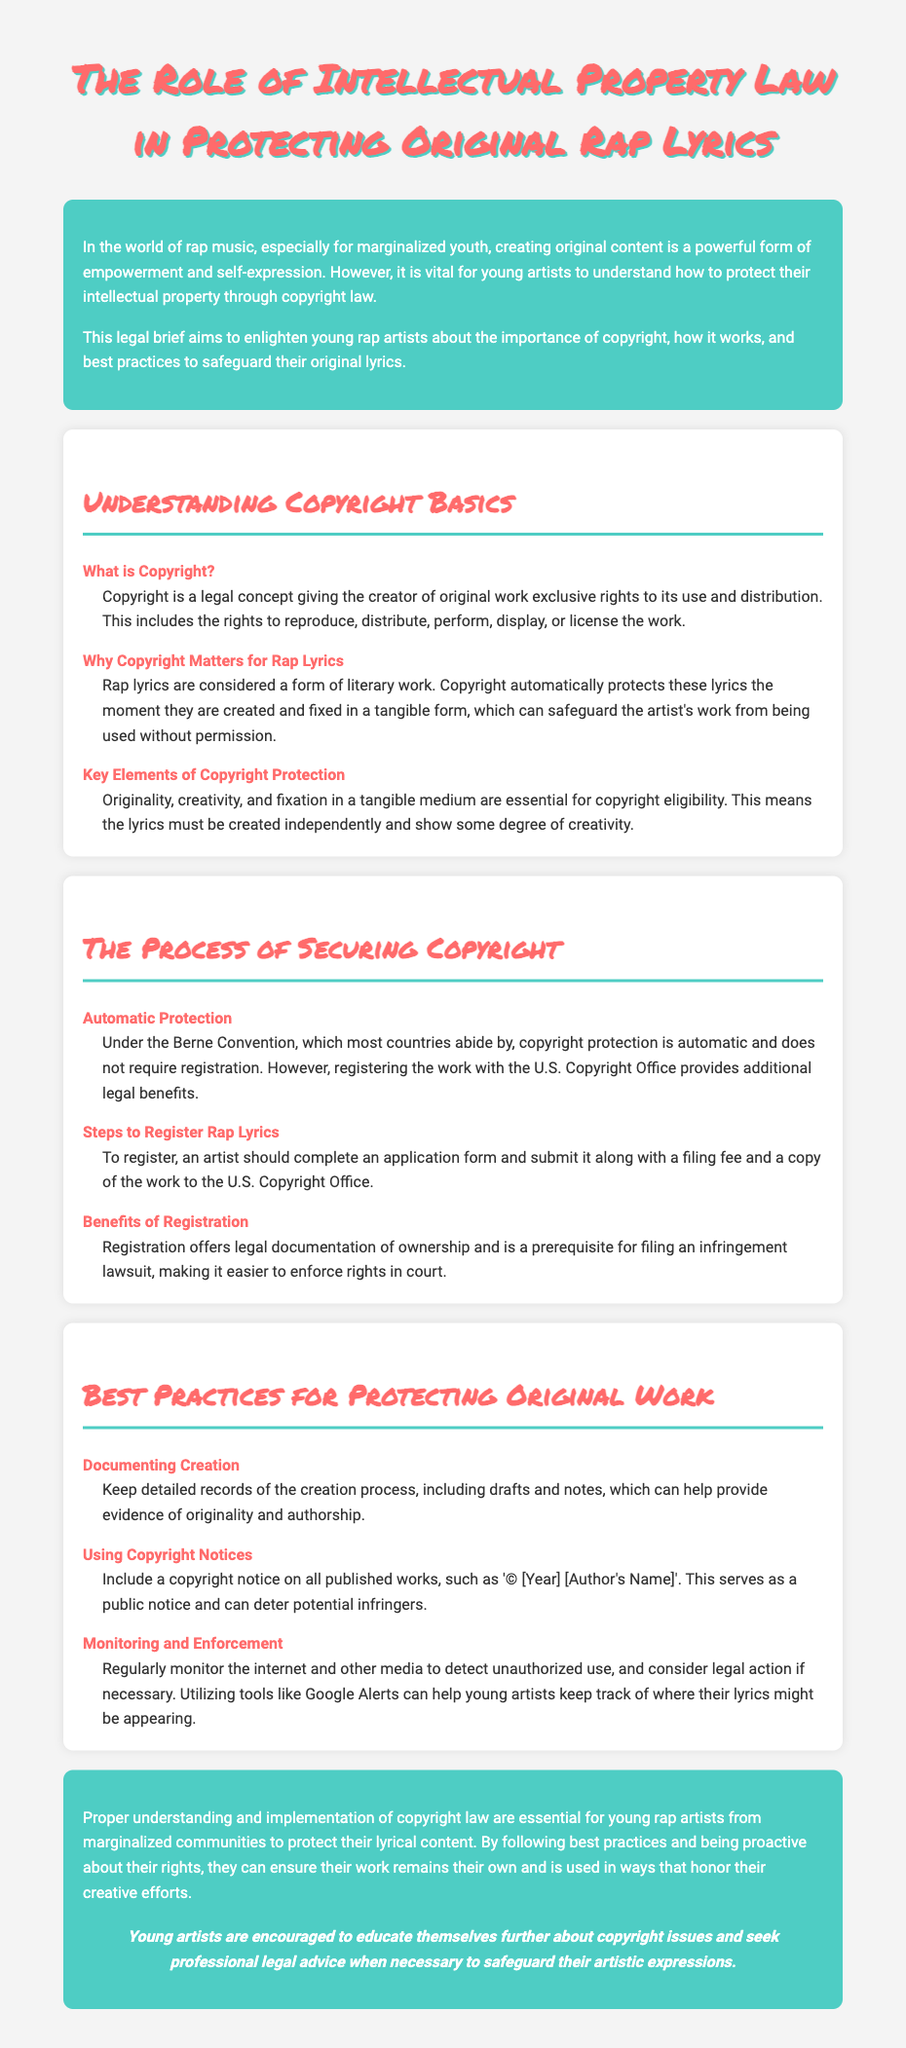What is the title of the document? The title is prominently displayed as the main heading of the document, introducing the topic at hand.
Answer: The Role of Intellectual Property Law in Protecting Original Rap Lyrics What is the legal concept that grants exclusive rights to creators? This concept is referred to in the section discussing copyright and its implications for original works.
Answer: Copyright What protects rap lyrics automatically upon creation? The document states that copyright automatically protects these lyrics when they are created and fixed in a tangible form.
Answer: Copyright What is one key element essential for copyright eligibility? Key elements required for protection are listed in the section about copyright basics, specifically noting characteristics that must be met.
Answer: Originality What is the prerequisite for filing an infringement lawsuit? The benefits of copyright registration are discussed, specifically identifying conditions necessary for legal action.
Answer: Registration What should young artists include on published works? The section on best practices for protecting original work mentions specific legal markings that deter infringement.
Answer: Copyright notice How can artists monitor unauthorized use of their lyrics? This information is provided in the best practices section detailing the ways to enforce rights and maintain awareness.
Answer: Google Alerts What document can provide additional legal benefits for copyright? The brief discusses the option to register with a specific organization for enhanced protection.
Answer: U.S. Copyright Office What is the main focus of the legal brief? The introduction outlines the brief’s purpose related to protection and education in the context of rap music.
Answer: Empowerment of marginalized youth 